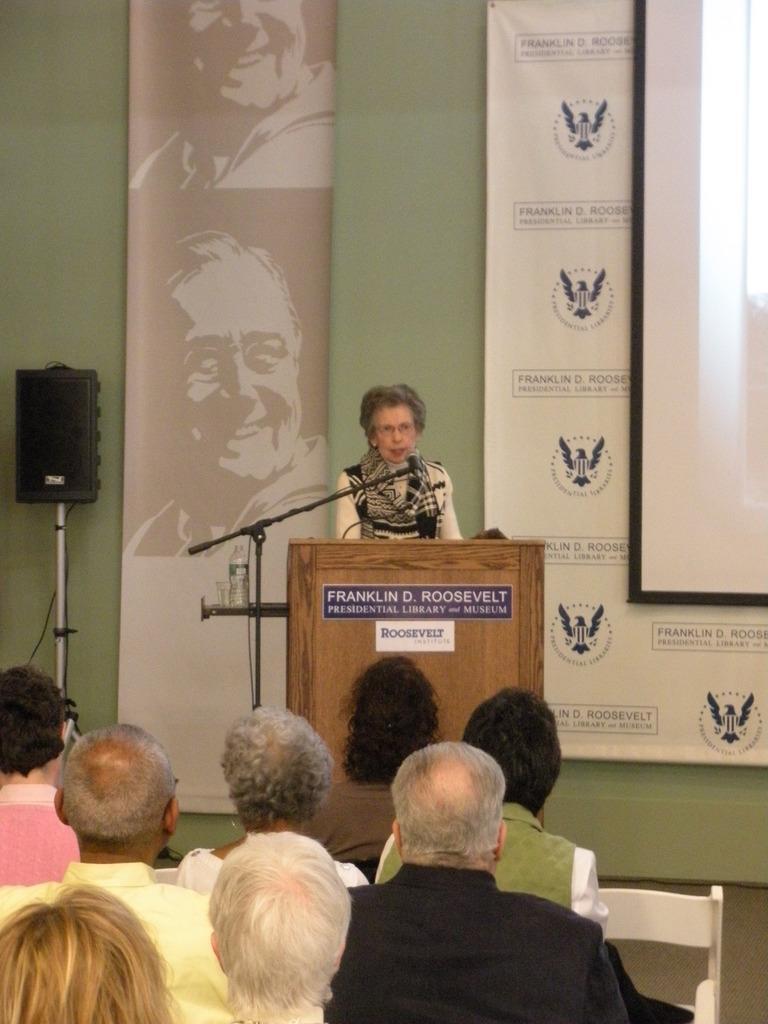How would you summarize this image in a sentence or two? In the center of the image we can see a lady standing, before her there is a podium and we can see a mic placed on the stand. On the left there is a speaker. At the bottom there are people sitting. In the background we can see a screen and boards placed on the wall. 